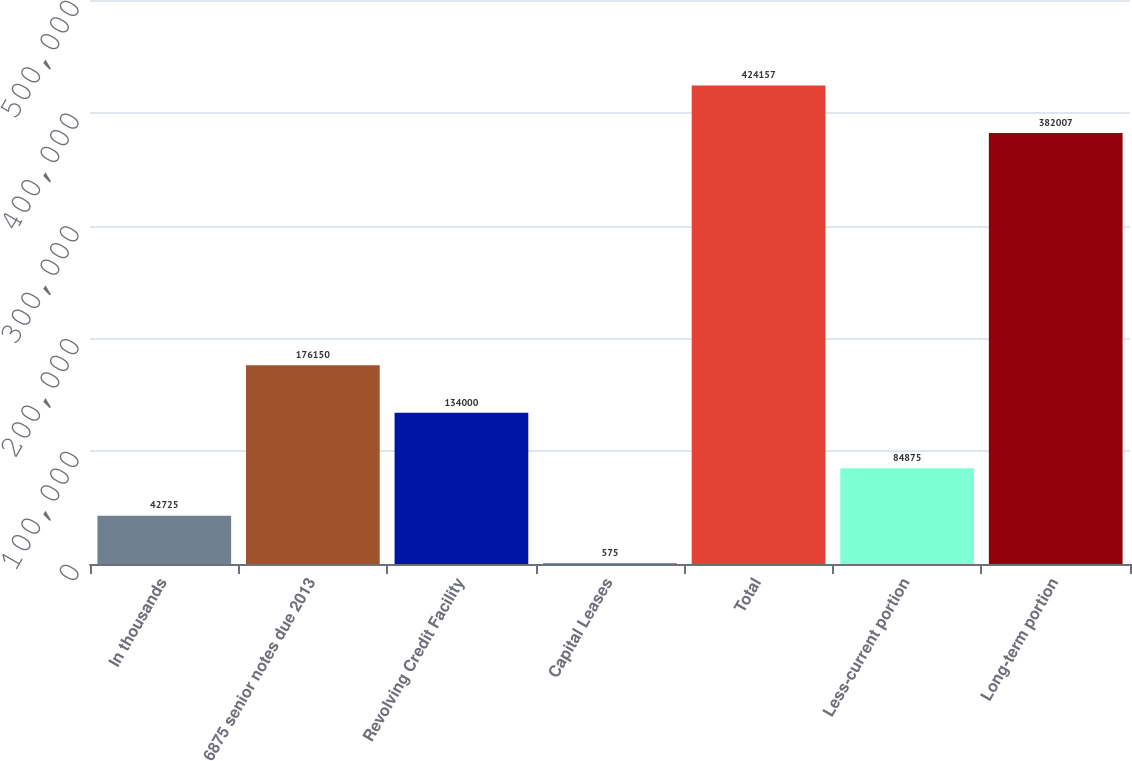Convert chart to OTSL. <chart><loc_0><loc_0><loc_500><loc_500><bar_chart><fcel>In thousands<fcel>6875 senior notes due 2013<fcel>Revolving Credit Facility<fcel>Capital Leases<fcel>Total<fcel>Less-current portion<fcel>Long-term portion<nl><fcel>42725<fcel>176150<fcel>134000<fcel>575<fcel>424157<fcel>84875<fcel>382007<nl></chart> 